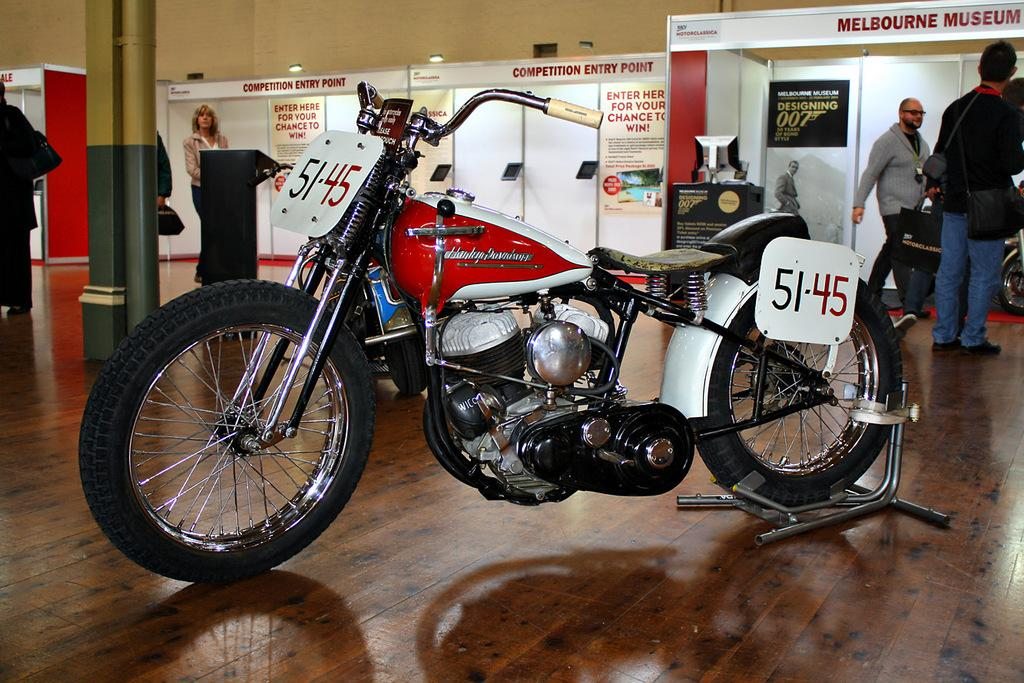What is the main object in the image? There is a bike in the image. What colors can be seen on the bike? The bike is in white and red color. Can you describe the people in the image? There are two men on the right side of the image, and a man is walking in the image. What type of cord is being used to hold the dinner during the protest in the image? There is no mention of a cord, dinner, or protest in the image; it features a bike and people. 